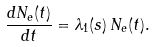Convert formula to latex. <formula><loc_0><loc_0><loc_500><loc_500>\frac { d N _ { e } ( t ) } { d t } = \lambda _ { 1 } ( s ) \, { N _ { e } ( t ) } .</formula> 